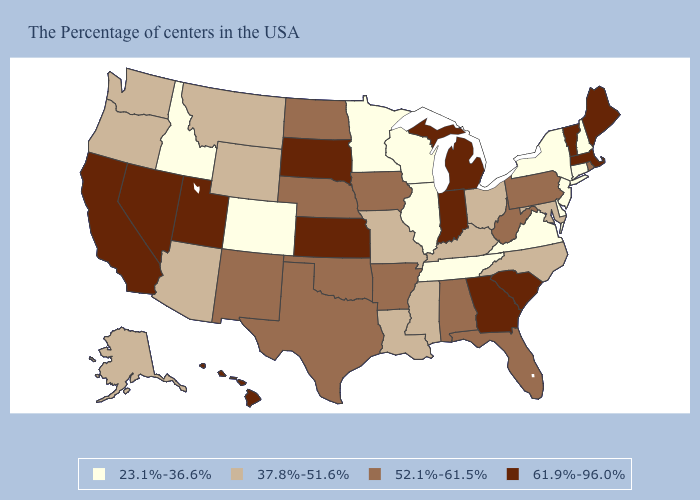Does Georgia have the highest value in the USA?
Give a very brief answer. Yes. Does Pennsylvania have the same value as Oklahoma?
Keep it brief. Yes. Name the states that have a value in the range 37.8%-51.6%?
Give a very brief answer. Maryland, North Carolina, Ohio, Kentucky, Mississippi, Louisiana, Missouri, Wyoming, Montana, Arizona, Washington, Oregon, Alaska. Which states have the lowest value in the USA?
Concise answer only. New Hampshire, Connecticut, New York, New Jersey, Delaware, Virginia, Tennessee, Wisconsin, Illinois, Minnesota, Colorado, Idaho. What is the value of Minnesota?
Write a very short answer. 23.1%-36.6%. What is the highest value in the Northeast ?
Quick response, please. 61.9%-96.0%. Does Hawaii have the highest value in the USA?
Concise answer only. Yes. Name the states that have a value in the range 52.1%-61.5%?
Short answer required. Rhode Island, Pennsylvania, West Virginia, Florida, Alabama, Arkansas, Iowa, Nebraska, Oklahoma, Texas, North Dakota, New Mexico. Among the states that border Idaho , does Oregon have the highest value?
Short answer required. No. What is the highest value in the MidWest ?
Answer briefly. 61.9%-96.0%. Does Montana have the lowest value in the West?
Give a very brief answer. No. What is the lowest value in the South?
Keep it brief. 23.1%-36.6%. Does Hawaii have the highest value in the USA?
Quick response, please. Yes. What is the lowest value in the MidWest?
Be succinct. 23.1%-36.6%. Name the states that have a value in the range 23.1%-36.6%?
Give a very brief answer. New Hampshire, Connecticut, New York, New Jersey, Delaware, Virginia, Tennessee, Wisconsin, Illinois, Minnesota, Colorado, Idaho. 